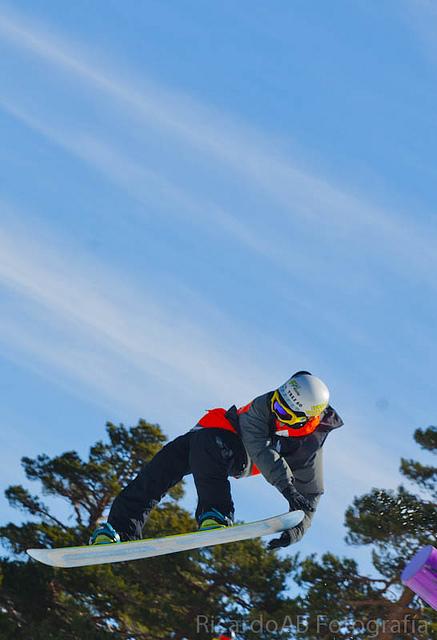What does the man have on his feet?
Answer briefly. Snowboard. What photographic angle was the picture taken?
Concise answer only. Low angle. What is the person riding?
Write a very short answer. Snowboard. 